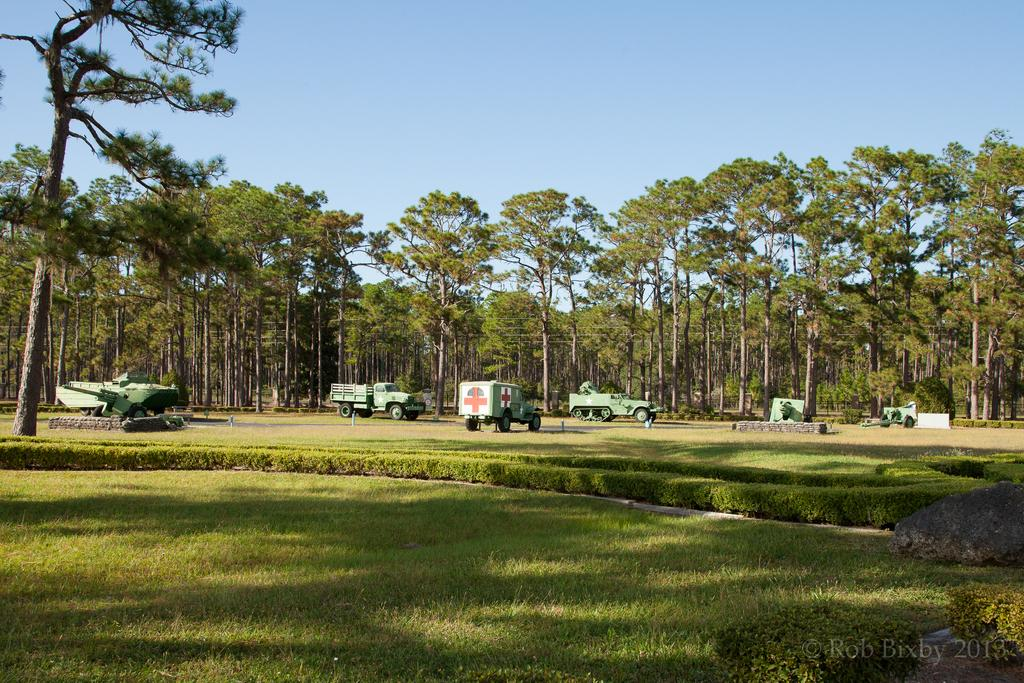What type of vegetation can be seen in the image? There is grass and bushes in the image. Are there any structures or objects related to transportation in the image? Yes, there are vehicles in the image. What type of natural elements are present in the image? There are trees in the image. What part of the natural environment is visible in the image? The sky is visible in the image. Can you describe any additional details visible in the bottom right of the image? There is a watermark, some text, and numbers visible in the bottom right of the image. Can you tell me how much honey is being produced by the bees in the image? There are no bees or honey present in the image; it features grass, bushes, vehicles, trees, the sky, and a watermark with text and numbers in the bottom right corner. Is there a zoo visible in the image? There is no zoo present in the image. 